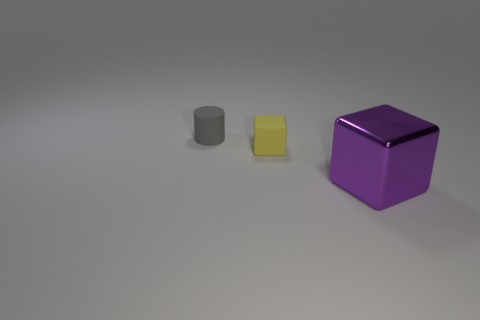Is there any other thing that has the same shape as the tiny gray object?
Ensure brevity in your answer.  No. What number of things are either small yellow rubber cubes or small matte things that are in front of the gray rubber object?
Your answer should be very brief. 1. There is another object that is the same shape as the small yellow thing; what material is it?
Your response must be concise. Metal. Is the shape of the matte object in front of the gray thing the same as  the purple shiny thing?
Provide a succinct answer. Yes. Is there anything else that is the same size as the gray thing?
Offer a very short reply. Yes. Is the number of tiny gray rubber cylinders that are in front of the purple thing less than the number of tiny cylinders that are to the right of the small block?
Your response must be concise. No. How many other objects are the same shape as the shiny thing?
Make the answer very short. 1. What is the size of the matte thing that is in front of the small rubber object that is behind the matte thing that is in front of the tiny gray cylinder?
Provide a succinct answer. Small. What number of purple things are either metallic objects or spheres?
Offer a terse response. 1. What is the shape of the thing to the right of the small matte thing that is to the right of the matte cylinder?
Give a very brief answer. Cube. 